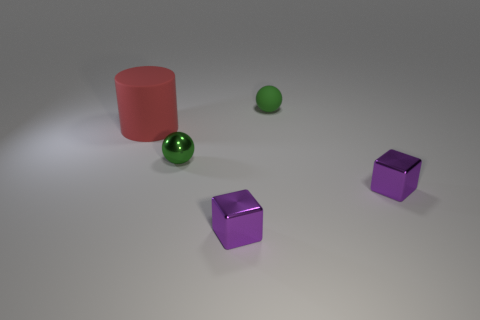Are there any other things that are the same size as the red rubber cylinder?
Your answer should be very brief. No. What is the color of the matte object behind the large matte object?
Provide a short and direct response. Green. There is another object that is the same shape as the tiny green metallic thing; what color is it?
Your response must be concise. Green. What number of green spheres are on the left side of the tiny green ball on the right side of the ball that is in front of the red matte thing?
Keep it short and to the point. 1. Is the number of small green metal things that are to the right of the small metal ball less than the number of tiny yellow cylinders?
Offer a very short reply. No. Is the tiny rubber object the same color as the metal sphere?
Provide a succinct answer. Yes. What is the size of the other object that is the same shape as the small matte thing?
Offer a very short reply. Small. What number of tiny green spheres have the same material as the red cylinder?
Offer a terse response. 1. Is the material of the tiny green thing behind the large thing the same as the red thing?
Your answer should be compact. Yes. Are there an equal number of green matte things in front of the cylinder and gray shiny balls?
Your answer should be very brief. Yes. 